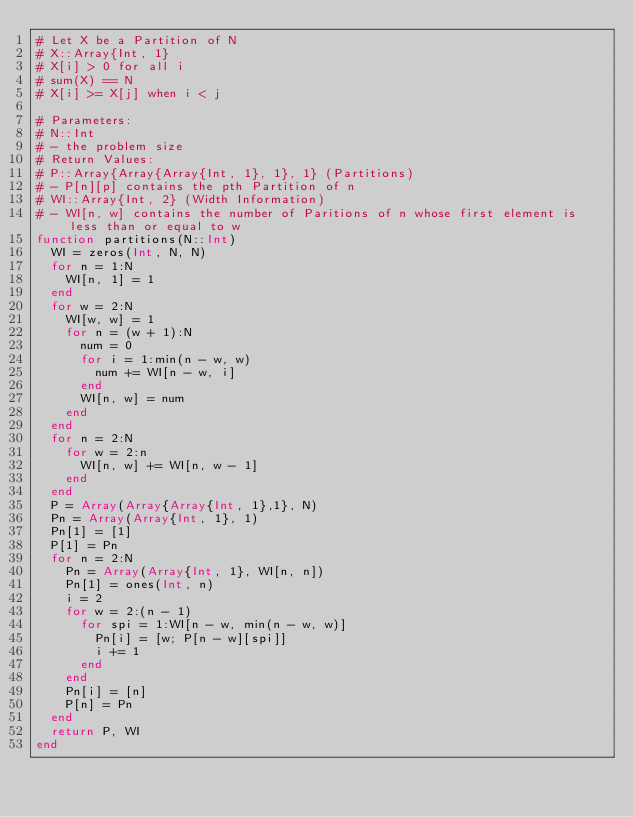<code> <loc_0><loc_0><loc_500><loc_500><_Julia_># Let X be a Partition of N
#	X::Array{Int, 1}
#	X[i] > 0 for all i
#	sum(X) == N
#	X[i] >= X[j] when i < j

# Parameters:
#	N::Int 
#	- the problem size
# Return Values:
#	P::Array{Array{Array{Int, 1}, 1}, 1} (Partitions)
#	- P[n][p] contains the pth Partition of n
#	WI::Array{Int, 2} (Width Information)
#	- WI[n, w] contains the number of Paritions of n whose first element is less than or equal to w
function partitions(N::Int)
	WI = zeros(Int, N, N) 
	for n = 1:N
		WI[n, 1] = 1
	end
	for w = 2:N
		WI[w, w] = 1
		for n = (w + 1):N
			num = 0
			for i = 1:min(n - w, w)
				num += WI[n - w, i]
			end
			WI[n, w] = num
		end
	end	
	for n = 2:N
		for w = 2:n
			WI[n, w] += WI[n, w - 1]
		end
	end	
	P = Array(Array{Array{Int, 1},1}, N)
	Pn = Array(Array{Int, 1}, 1)
	Pn[1] = [1]
	P[1] = Pn
	for n = 2:N
		Pn = Array(Array{Int, 1}, WI[n, n])
		Pn[1] = ones(Int, n)
		i = 2
		for w = 2:(n - 1)
			for spi = 1:WI[n - w, min(n - w, w)] 
				Pn[i] = [w; P[n - w][spi]]
				i += 1
			end
		end
		Pn[i] = [n]
		P[n] = Pn
	end
	return P, WI
end

</code> 